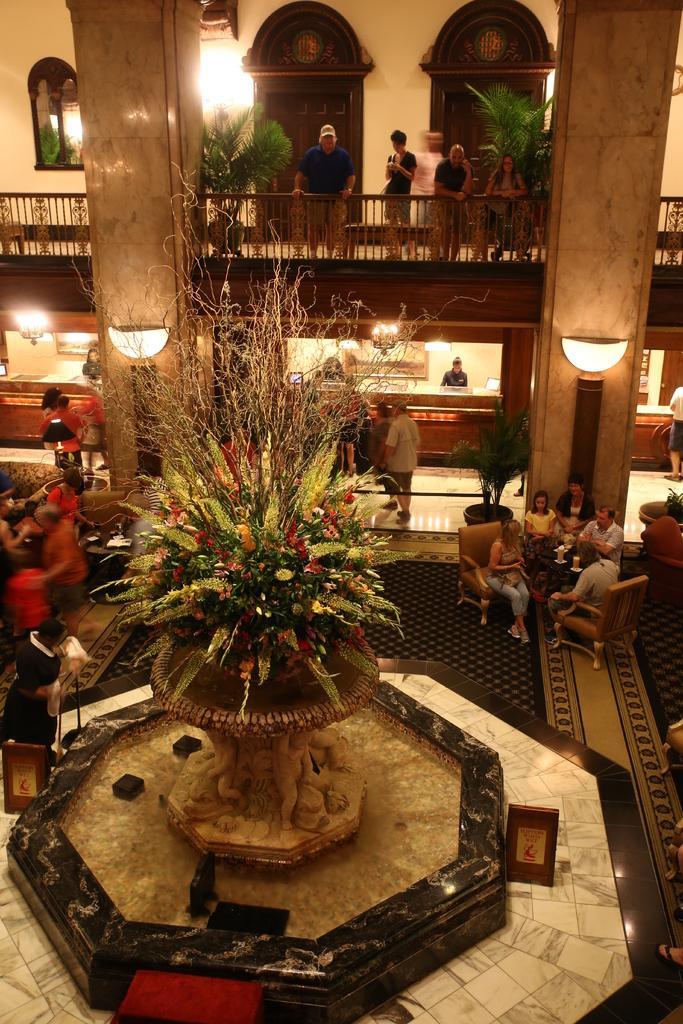In one or two sentences, can you explain what this image depicts? In this image we can see the inner view of a building and there are some people and among them few people are standing. We can see an object in the middle of the image and it looks like a large flower vase and there are some potted plants and we can see some lights attached to the wall. 